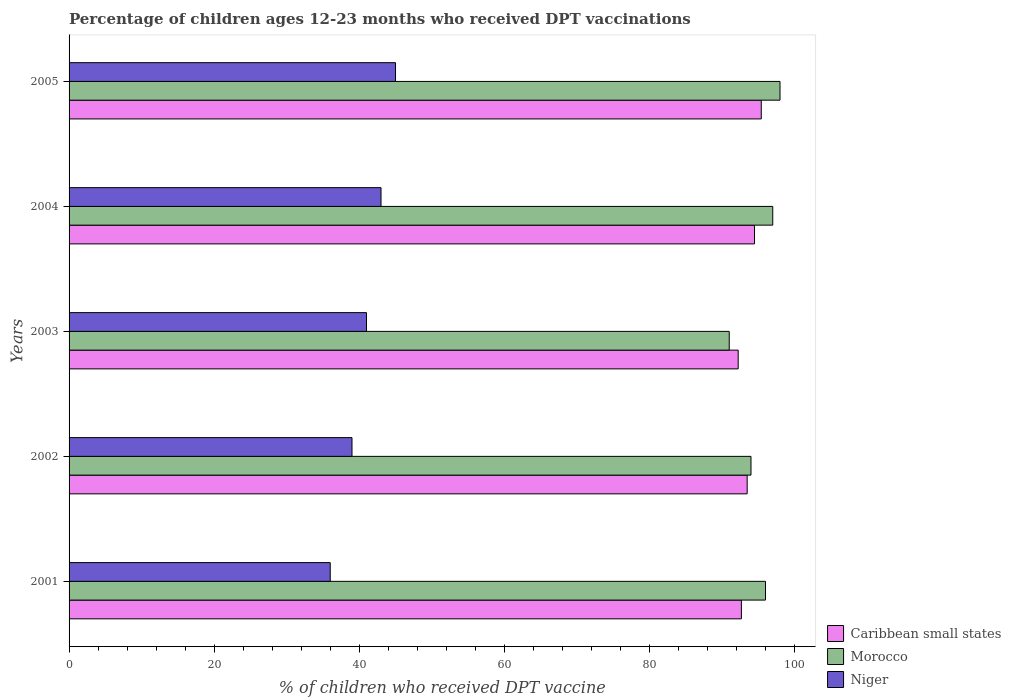How many different coloured bars are there?
Keep it short and to the point. 3. Are the number of bars per tick equal to the number of legend labels?
Keep it short and to the point. Yes. Are the number of bars on each tick of the Y-axis equal?
Keep it short and to the point. Yes. How many bars are there on the 4th tick from the top?
Keep it short and to the point. 3. How many bars are there on the 1st tick from the bottom?
Your answer should be compact. 3. What is the label of the 1st group of bars from the top?
Keep it short and to the point. 2005. In how many cases, is the number of bars for a given year not equal to the number of legend labels?
Your answer should be compact. 0. What is the percentage of children who received DPT vaccination in Niger in 2003?
Provide a succinct answer. 41. Across all years, what is the maximum percentage of children who received DPT vaccination in Caribbean small states?
Keep it short and to the point. 95.42. Across all years, what is the minimum percentage of children who received DPT vaccination in Niger?
Your answer should be compact. 36. In which year was the percentage of children who received DPT vaccination in Caribbean small states maximum?
Your answer should be very brief. 2005. What is the total percentage of children who received DPT vaccination in Morocco in the graph?
Offer a very short reply. 476. What is the difference between the percentage of children who received DPT vaccination in Caribbean small states in 2001 and that in 2005?
Provide a short and direct response. -2.74. What is the difference between the percentage of children who received DPT vaccination in Niger in 2005 and the percentage of children who received DPT vaccination in Morocco in 2002?
Keep it short and to the point. -49. What is the average percentage of children who received DPT vaccination in Niger per year?
Keep it short and to the point. 40.8. In how many years, is the percentage of children who received DPT vaccination in Niger greater than 64 %?
Give a very brief answer. 0. What is the ratio of the percentage of children who received DPT vaccination in Morocco in 2003 to that in 2005?
Keep it short and to the point. 0.93. Is the percentage of children who received DPT vaccination in Morocco in 2001 less than that in 2002?
Provide a short and direct response. No. Is the difference between the percentage of children who received DPT vaccination in Niger in 2001 and 2002 greater than the difference between the percentage of children who received DPT vaccination in Morocco in 2001 and 2002?
Offer a very short reply. No. What is the difference between the highest and the lowest percentage of children who received DPT vaccination in Morocco?
Your response must be concise. 7. Is the sum of the percentage of children who received DPT vaccination in Niger in 2001 and 2004 greater than the maximum percentage of children who received DPT vaccination in Caribbean small states across all years?
Your answer should be compact. No. What does the 2nd bar from the top in 2005 represents?
Your answer should be compact. Morocco. What does the 1st bar from the bottom in 2003 represents?
Your response must be concise. Caribbean small states. How many bars are there?
Your response must be concise. 15. Are all the bars in the graph horizontal?
Offer a terse response. Yes. How many years are there in the graph?
Provide a short and direct response. 5. Are the values on the major ticks of X-axis written in scientific E-notation?
Give a very brief answer. No. Does the graph contain any zero values?
Your response must be concise. No. Does the graph contain grids?
Make the answer very short. No. Where does the legend appear in the graph?
Keep it short and to the point. Bottom right. How many legend labels are there?
Your answer should be very brief. 3. What is the title of the graph?
Your answer should be compact. Percentage of children ages 12-23 months who received DPT vaccinations. What is the label or title of the X-axis?
Provide a succinct answer. % of children who received DPT vaccine. What is the % of children who received DPT vaccine of Caribbean small states in 2001?
Offer a very short reply. 92.68. What is the % of children who received DPT vaccine in Morocco in 2001?
Give a very brief answer. 96. What is the % of children who received DPT vaccine in Niger in 2001?
Offer a very short reply. 36. What is the % of children who received DPT vaccine of Caribbean small states in 2002?
Your answer should be very brief. 93.47. What is the % of children who received DPT vaccine in Morocco in 2002?
Make the answer very short. 94. What is the % of children who received DPT vaccine in Niger in 2002?
Provide a succinct answer. 39. What is the % of children who received DPT vaccine in Caribbean small states in 2003?
Give a very brief answer. 92.23. What is the % of children who received DPT vaccine in Morocco in 2003?
Give a very brief answer. 91. What is the % of children who received DPT vaccine in Caribbean small states in 2004?
Your response must be concise. 94.49. What is the % of children who received DPT vaccine of Morocco in 2004?
Offer a very short reply. 97. What is the % of children who received DPT vaccine in Caribbean small states in 2005?
Give a very brief answer. 95.42. What is the % of children who received DPT vaccine of Niger in 2005?
Make the answer very short. 45. Across all years, what is the maximum % of children who received DPT vaccine in Caribbean small states?
Provide a short and direct response. 95.42. Across all years, what is the maximum % of children who received DPT vaccine of Morocco?
Your answer should be very brief. 98. Across all years, what is the minimum % of children who received DPT vaccine in Caribbean small states?
Your answer should be compact. 92.23. Across all years, what is the minimum % of children who received DPT vaccine in Morocco?
Provide a succinct answer. 91. What is the total % of children who received DPT vaccine in Caribbean small states in the graph?
Your response must be concise. 468.29. What is the total % of children who received DPT vaccine in Morocco in the graph?
Keep it short and to the point. 476. What is the total % of children who received DPT vaccine of Niger in the graph?
Keep it short and to the point. 204. What is the difference between the % of children who received DPT vaccine of Caribbean small states in 2001 and that in 2002?
Keep it short and to the point. -0.8. What is the difference between the % of children who received DPT vaccine in Morocco in 2001 and that in 2002?
Offer a very short reply. 2. What is the difference between the % of children who received DPT vaccine of Caribbean small states in 2001 and that in 2003?
Ensure brevity in your answer.  0.44. What is the difference between the % of children who received DPT vaccine of Morocco in 2001 and that in 2003?
Keep it short and to the point. 5. What is the difference between the % of children who received DPT vaccine of Niger in 2001 and that in 2003?
Offer a very short reply. -5. What is the difference between the % of children who received DPT vaccine of Caribbean small states in 2001 and that in 2004?
Provide a succinct answer. -1.81. What is the difference between the % of children who received DPT vaccine of Niger in 2001 and that in 2004?
Offer a terse response. -7. What is the difference between the % of children who received DPT vaccine of Caribbean small states in 2001 and that in 2005?
Your response must be concise. -2.74. What is the difference between the % of children who received DPT vaccine in Caribbean small states in 2002 and that in 2003?
Give a very brief answer. 1.24. What is the difference between the % of children who received DPT vaccine of Niger in 2002 and that in 2003?
Offer a very short reply. -2. What is the difference between the % of children who received DPT vaccine of Caribbean small states in 2002 and that in 2004?
Offer a terse response. -1.01. What is the difference between the % of children who received DPT vaccine of Morocco in 2002 and that in 2004?
Your response must be concise. -3. What is the difference between the % of children who received DPT vaccine of Caribbean small states in 2002 and that in 2005?
Your answer should be very brief. -1.94. What is the difference between the % of children who received DPT vaccine in Caribbean small states in 2003 and that in 2004?
Your response must be concise. -2.25. What is the difference between the % of children who received DPT vaccine in Niger in 2003 and that in 2004?
Provide a succinct answer. -2. What is the difference between the % of children who received DPT vaccine in Caribbean small states in 2003 and that in 2005?
Offer a very short reply. -3.18. What is the difference between the % of children who received DPT vaccine of Niger in 2003 and that in 2005?
Your response must be concise. -4. What is the difference between the % of children who received DPT vaccine of Caribbean small states in 2004 and that in 2005?
Provide a succinct answer. -0.93. What is the difference between the % of children who received DPT vaccine of Niger in 2004 and that in 2005?
Provide a short and direct response. -2. What is the difference between the % of children who received DPT vaccine of Caribbean small states in 2001 and the % of children who received DPT vaccine of Morocco in 2002?
Your answer should be very brief. -1.32. What is the difference between the % of children who received DPT vaccine in Caribbean small states in 2001 and the % of children who received DPT vaccine in Niger in 2002?
Provide a short and direct response. 53.68. What is the difference between the % of children who received DPT vaccine in Morocco in 2001 and the % of children who received DPT vaccine in Niger in 2002?
Keep it short and to the point. 57. What is the difference between the % of children who received DPT vaccine in Caribbean small states in 2001 and the % of children who received DPT vaccine in Morocco in 2003?
Your response must be concise. 1.68. What is the difference between the % of children who received DPT vaccine in Caribbean small states in 2001 and the % of children who received DPT vaccine in Niger in 2003?
Your answer should be compact. 51.68. What is the difference between the % of children who received DPT vaccine in Morocco in 2001 and the % of children who received DPT vaccine in Niger in 2003?
Make the answer very short. 55. What is the difference between the % of children who received DPT vaccine in Caribbean small states in 2001 and the % of children who received DPT vaccine in Morocco in 2004?
Offer a terse response. -4.32. What is the difference between the % of children who received DPT vaccine in Caribbean small states in 2001 and the % of children who received DPT vaccine in Niger in 2004?
Make the answer very short. 49.68. What is the difference between the % of children who received DPT vaccine of Morocco in 2001 and the % of children who received DPT vaccine of Niger in 2004?
Make the answer very short. 53. What is the difference between the % of children who received DPT vaccine in Caribbean small states in 2001 and the % of children who received DPT vaccine in Morocco in 2005?
Your answer should be compact. -5.32. What is the difference between the % of children who received DPT vaccine in Caribbean small states in 2001 and the % of children who received DPT vaccine in Niger in 2005?
Your response must be concise. 47.68. What is the difference between the % of children who received DPT vaccine of Caribbean small states in 2002 and the % of children who received DPT vaccine of Morocco in 2003?
Your answer should be very brief. 2.47. What is the difference between the % of children who received DPT vaccine in Caribbean small states in 2002 and the % of children who received DPT vaccine in Niger in 2003?
Your answer should be compact. 52.47. What is the difference between the % of children who received DPT vaccine of Caribbean small states in 2002 and the % of children who received DPT vaccine of Morocco in 2004?
Make the answer very short. -3.53. What is the difference between the % of children who received DPT vaccine in Caribbean small states in 2002 and the % of children who received DPT vaccine in Niger in 2004?
Make the answer very short. 50.47. What is the difference between the % of children who received DPT vaccine of Morocco in 2002 and the % of children who received DPT vaccine of Niger in 2004?
Keep it short and to the point. 51. What is the difference between the % of children who received DPT vaccine in Caribbean small states in 2002 and the % of children who received DPT vaccine in Morocco in 2005?
Offer a terse response. -4.53. What is the difference between the % of children who received DPT vaccine of Caribbean small states in 2002 and the % of children who received DPT vaccine of Niger in 2005?
Give a very brief answer. 48.47. What is the difference between the % of children who received DPT vaccine of Morocco in 2002 and the % of children who received DPT vaccine of Niger in 2005?
Provide a short and direct response. 49. What is the difference between the % of children who received DPT vaccine of Caribbean small states in 2003 and the % of children who received DPT vaccine of Morocco in 2004?
Keep it short and to the point. -4.77. What is the difference between the % of children who received DPT vaccine in Caribbean small states in 2003 and the % of children who received DPT vaccine in Niger in 2004?
Ensure brevity in your answer.  49.23. What is the difference between the % of children who received DPT vaccine in Caribbean small states in 2003 and the % of children who received DPT vaccine in Morocco in 2005?
Your response must be concise. -5.77. What is the difference between the % of children who received DPT vaccine of Caribbean small states in 2003 and the % of children who received DPT vaccine of Niger in 2005?
Give a very brief answer. 47.23. What is the difference between the % of children who received DPT vaccine of Caribbean small states in 2004 and the % of children who received DPT vaccine of Morocco in 2005?
Your answer should be compact. -3.51. What is the difference between the % of children who received DPT vaccine in Caribbean small states in 2004 and the % of children who received DPT vaccine in Niger in 2005?
Give a very brief answer. 49.49. What is the difference between the % of children who received DPT vaccine of Morocco in 2004 and the % of children who received DPT vaccine of Niger in 2005?
Your answer should be compact. 52. What is the average % of children who received DPT vaccine of Caribbean small states per year?
Offer a terse response. 93.66. What is the average % of children who received DPT vaccine in Morocco per year?
Your response must be concise. 95.2. What is the average % of children who received DPT vaccine of Niger per year?
Make the answer very short. 40.8. In the year 2001, what is the difference between the % of children who received DPT vaccine in Caribbean small states and % of children who received DPT vaccine in Morocco?
Provide a short and direct response. -3.32. In the year 2001, what is the difference between the % of children who received DPT vaccine in Caribbean small states and % of children who received DPT vaccine in Niger?
Provide a short and direct response. 56.68. In the year 2002, what is the difference between the % of children who received DPT vaccine in Caribbean small states and % of children who received DPT vaccine in Morocco?
Make the answer very short. -0.53. In the year 2002, what is the difference between the % of children who received DPT vaccine in Caribbean small states and % of children who received DPT vaccine in Niger?
Provide a short and direct response. 54.47. In the year 2002, what is the difference between the % of children who received DPT vaccine of Morocco and % of children who received DPT vaccine of Niger?
Offer a very short reply. 55. In the year 2003, what is the difference between the % of children who received DPT vaccine in Caribbean small states and % of children who received DPT vaccine in Morocco?
Make the answer very short. 1.23. In the year 2003, what is the difference between the % of children who received DPT vaccine of Caribbean small states and % of children who received DPT vaccine of Niger?
Provide a succinct answer. 51.23. In the year 2004, what is the difference between the % of children who received DPT vaccine in Caribbean small states and % of children who received DPT vaccine in Morocco?
Make the answer very short. -2.51. In the year 2004, what is the difference between the % of children who received DPT vaccine in Caribbean small states and % of children who received DPT vaccine in Niger?
Provide a short and direct response. 51.49. In the year 2004, what is the difference between the % of children who received DPT vaccine in Morocco and % of children who received DPT vaccine in Niger?
Keep it short and to the point. 54. In the year 2005, what is the difference between the % of children who received DPT vaccine of Caribbean small states and % of children who received DPT vaccine of Morocco?
Provide a succinct answer. -2.58. In the year 2005, what is the difference between the % of children who received DPT vaccine of Caribbean small states and % of children who received DPT vaccine of Niger?
Ensure brevity in your answer.  50.42. In the year 2005, what is the difference between the % of children who received DPT vaccine in Morocco and % of children who received DPT vaccine in Niger?
Offer a terse response. 53. What is the ratio of the % of children who received DPT vaccine in Morocco in 2001 to that in 2002?
Your answer should be compact. 1.02. What is the ratio of the % of children who received DPT vaccine in Morocco in 2001 to that in 2003?
Ensure brevity in your answer.  1.05. What is the ratio of the % of children who received DPT vaccine of Niger in 2001 to that in 2003?
Your answer should be compact. 0.88. What is the ratio of the % of children who received DPT vaccine in Caribbean small states in 2001 to that in 2004?
Your answer should be compact. 0.98. What is the ratio of the % of children who received DPT vaccine in Niger in 2001 to that in 2004?
Ensure brevity in your answer.  0.84. What is the ratio of the % of children who received DPT vaccine in Caribbean small states in 2001 to that in 2005?
Your answer should be compact. 0.97. What is the ratio of the % of children who received DPT vaccine of Morocco in 2001 to that in 2005?
Keep it short and to the point. 0.98. What is the ratio of the % of children who received DPT vaccine of Caribbean small states in 2002 to that in 2003?
Ensure brevity in your answer.  1.01. What is the ratio of the % of children who received DPT vaccine of Morocco in 2002 to that in 2003?
Offer a terse response. 1.03. What is the ratio of the % of children who received DPT vaccine in Niger in 2002 to that in 2003?
Offer a terse response. 0.95. What is the ratio of the % of children who received DPT vaccine in Caribbean small states in 2002 to that in 2004?
Offer a very short reply. 0.99. What is the ratio of the % of children who received DPT vaccine of Morocco in 2002 to that in 2004?
Give a very brief answer. 0.97. What is the ratio of the % of children who received DPT vaccine of Niger in 2002 to that in 2004?
Your response must be concise. 0.91. What is the ratio of the % of children who received DPT vaccine of Caribbean small states in 2002 to that in 2005?
Provide a succinct answer. 0.98. What is the ratio of the % of children who received DPT vaccine in Morocco in 2002 to that in 2005?
Make the answer very short. 0.96. What is the ratio of the % of children who received DPT vaccine of Niger in 2002 to that in 2005?
Your answer should be very brief. 0.87. What is the ratio of the % of children who received DPT vaccine of Caribbean small states in 2003 to that in 2004?
Your response must be concise. 0.98. What is the ratio of the % of children who received DPT vaccine of Morocco in 2003 to that in 2004?
Make the answer very short. 0.94. What is the ratio of the % of children who received DPT vaccine of Niger in 2003 to that in 2004?
Keep it short and to the point. 0.95. What is the ratio of the % of children who received DPT vaccine in Caribbean small states in 2003 to that in 2005?
Ensure brevity in your answer.  0.97. What is the ratio of the % of children who received DPT vaccine of Niger in 2003 to that in 2005?
Provide a succinct answer. 0.91. What is the ratio of the % of children who received DPT vaccine of Caribbean small states in 2004 to that in 2005?
Give a very brief answer. 0.99. What is the ratio of the % of children who received DPT vaccine in Morocco in 2004 to that in 2005?
Your response must be concise. 0.99. What is the ratio of the % of children who received DPT vaccine of Niger in 2004 to that in 2005?
Keep it short and to the point. 0.96. What is the difference between the highest and the second highest % of children who received DPT vaccine in Caribbean small states?
Offer a terse response. 0.93. What is the difference between the highest and the second highest % of children who received DPT vaccine of Morocco?
Ensure brevity in your answer.  1. What is the difference between the highest and the lowest % of children who received DPT vaccine in Caribbean small states?
Offer a terse response. 3.18. What is the difference between the highest and the lowest % of children who received DPT vaccine of Morocco?
Give a very brief answer. 7. What is the difference between the highest and the lowest % of children who received DPT vaccine of Niger?
Ensure brevity in your answer.  9. 